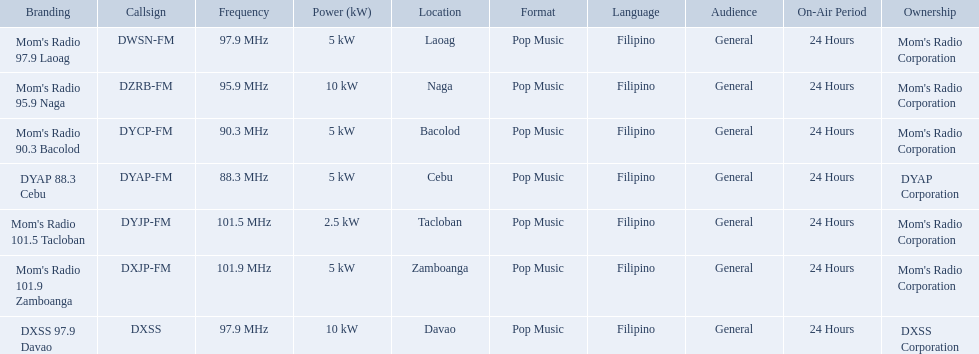What are the frequencies for radios of dyap-fm? 97.9 MHz, 95.9 MHz, 90.3 MHz, 88.3 MHz, 101.5 MHz, 101.9 MHz, 97.9 MHz. What is the lowest frequency? 88.3 MHz. Which radio has this frequency? DYAP 88.3 Cebu. 